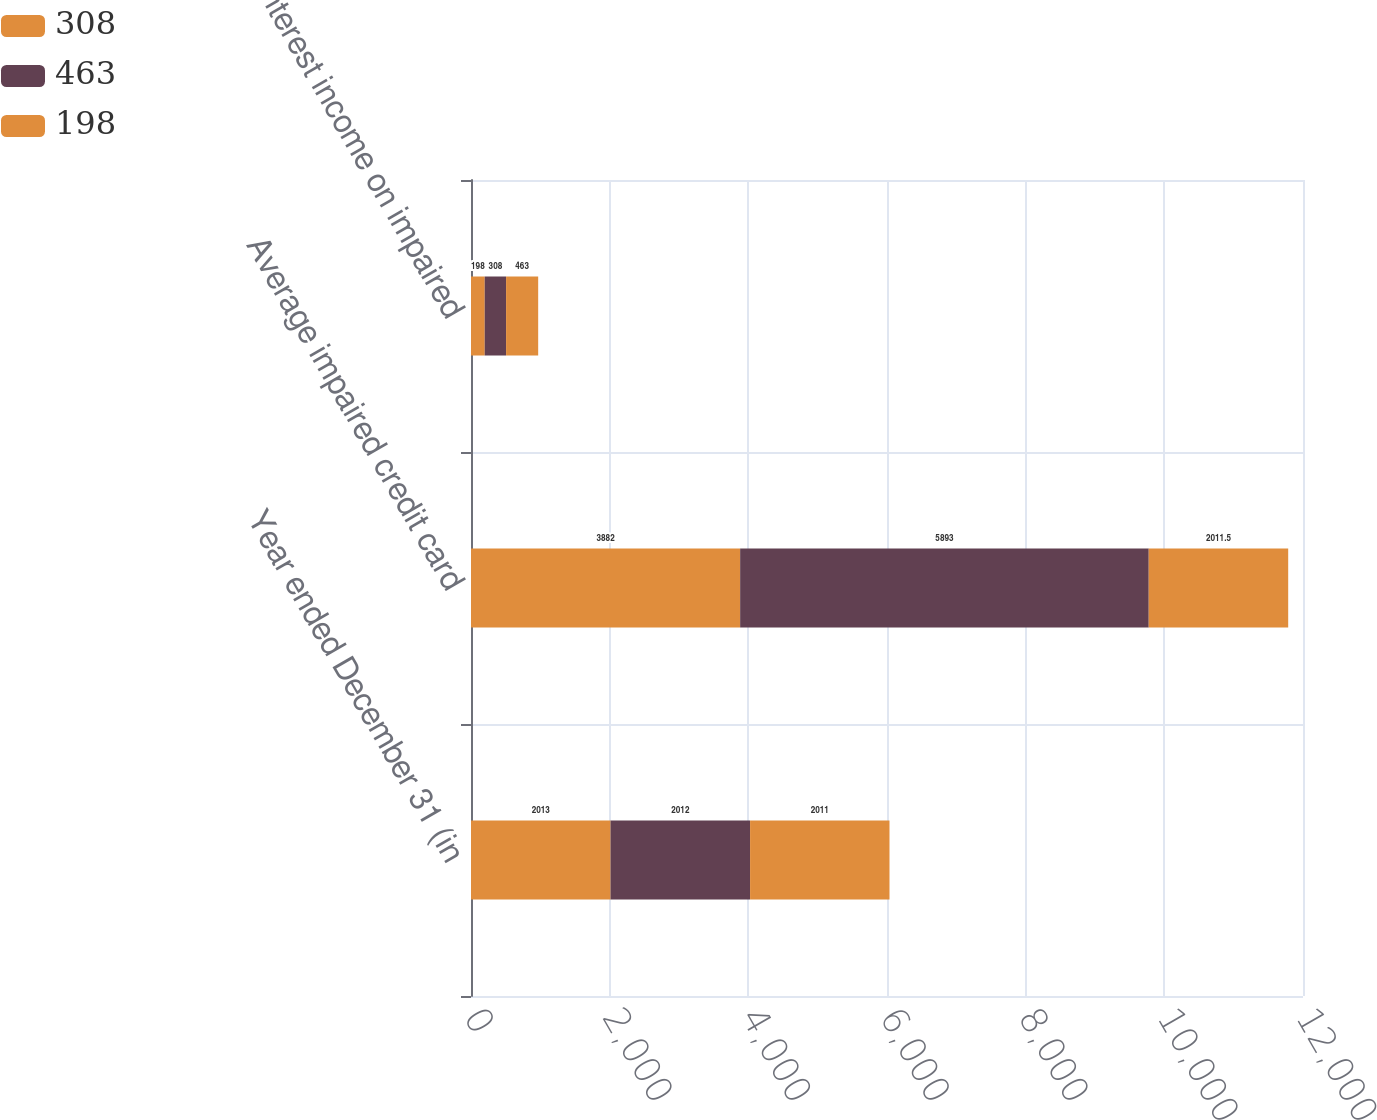<chart> <loc_0><loc_0><loc_500><loc_500><stacked_bar_chart><ecel><fcel>Year ended December 31 (in<fcel>Average impaired credit card<fcel>Interest income on impaired<nl><fcel>308<fcel>2013<fcel>3882<fcel>198<nl><fcel>463<fcel>2012<fcel>5893<fcel>308<nl><fcel>198<fcel>2011<fcel>2011.5<fcel>463<nl></chart> 